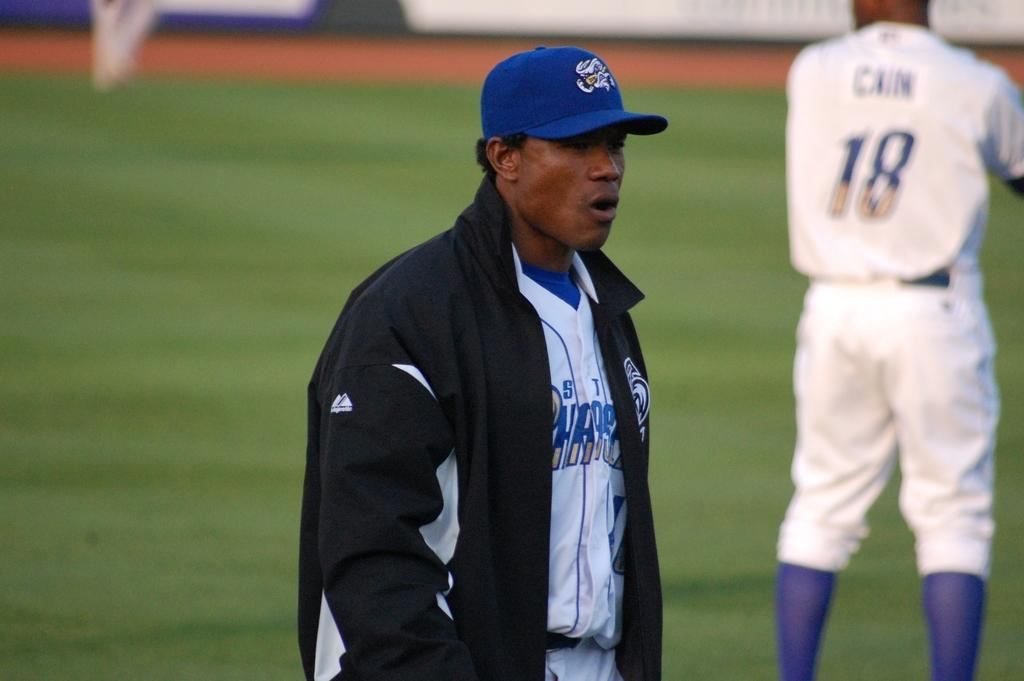<image>
Share a concise interpretation of the image provided. A man in a baseball cap and jacket stands on the baseball field in front of a player with the number 18 and the name Cain on their jersey. 